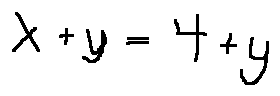<formula> <loc_0><loc_0><loc_500><loc_500>x + y = 4 + y</formula> 